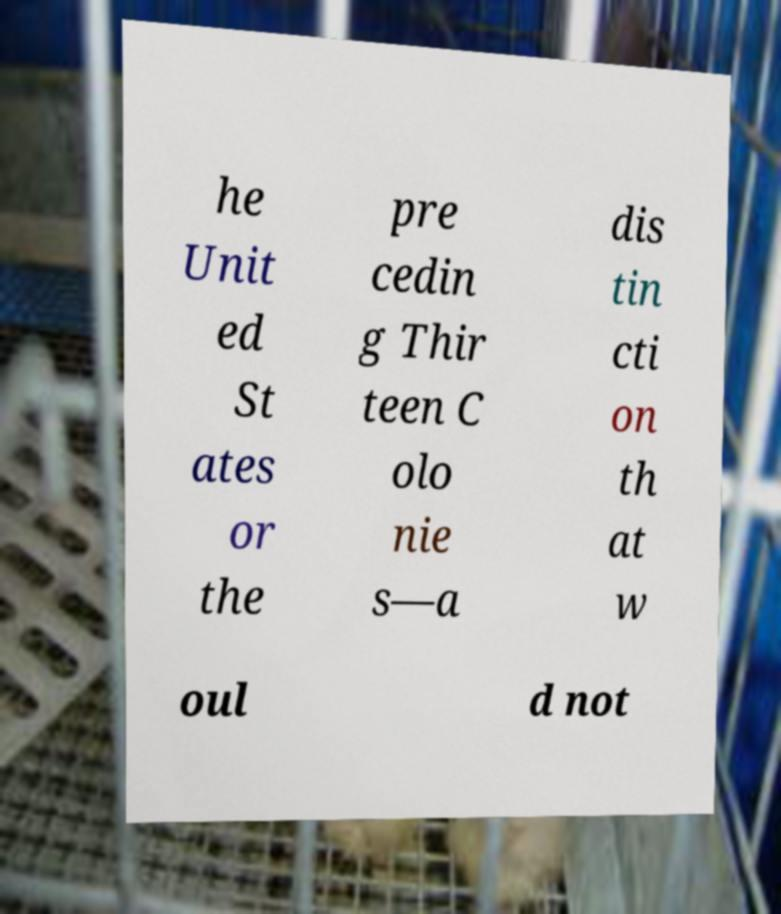For documentation purposes, I need the text within this image transcribed. Could you provide that? he Unit ed St ates or the pre cedin g Thir teen C olo nie s—a dis tin cti on th at w oul d not 